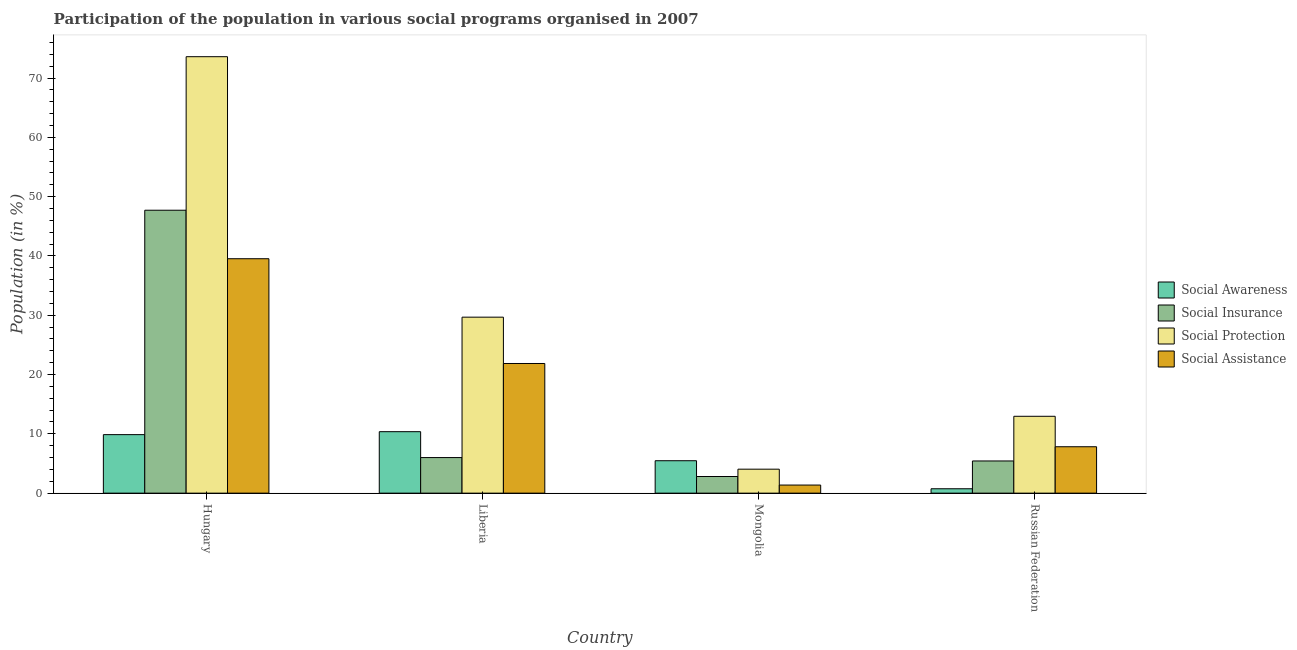How many bars are there on the 2nd tick from the right?
Provide a succinct answer. 4. What is the label of the 2nd group of bars from the left?
Keep it short and to the point. Liberia. In how many cases, is the number of bars for a given country not equal to the number of legend labels?
Provide a short and direct response. 0. What is the participation of population in social assistance programs in Russian Federation?
Ensure brevity in your answer.  7.83. Across all countries, what is the maximum participation of population in social assistance programs?
Your response must be concise. 39.53. Across all countries, what is the minimum participation of population in social protection programs?
Offer a very short reply. 4.04. In which country was the participation of population in social assistance programs maximum?
Your answer should be compact. Hungary. In which country was the participation of population in social awareness programs minimum?
Give a very brief answer. Russian Federation. What is the total participation of population in social assistance programs in the graph?
Your answer should be compact. 70.59. What is the difference between the participation of population in social protection programs in Liberia and that in Russian Federation?
Your answer should be very brief. 16.72. What is the difference between the participation of population in social assistance programs in Liberia and the participation of population in social protection programs in Hungary?
Keep it short and to the point. -51.74. What is the average participation of population in social awareness programs per country?
Offer a very short reply. 6.61. What is the difference between the participation of population in social protection programs and participation of population in social assistance programs in Hungary?
Give a very brief answer. 34.07. In how many countries, is the participation of population in social awareness programs greater than 46 %?
Ensure brevity in your answer.  0. What is the ratio of the participation of population in social insurance programs in Hungary to that in Russian Federation?
Your answer should be compact. 8.79. What is the difference between the highest and the second highest participation of population in social insurance programs?
Provide a short and direct response. 41.71. What is the difference between the highest and the lowest participation of population in social insurance programs?
Make the answer very short. 44.91. Is the sum of the participation of population in social protection programs in Hungary and Mongolia greater than the maximum participation of population in social awareness programs across all countries?
Provide a short and direct response. Yes. Is it the case that in every country, the sum of the participation of population in social awareness programs and participation of population in social protection programs is greater than the sum of participation of population in social assistance programs and participation of population in social insurance programs?
Offer a very short reply. No. What does the 1st bar from the left in Russian Federation represents?
Provide a succinct answer. Social Awareness. What does the 2nd bar from the right in Hungary represents?
Offer a terse response. Social Protection. How many bars are there?
Provide a short and direct response. 16. How many countries are there in the graph?
Provide a succinct answer. 4. What is the difference between two consecutive major ticks on the Y-axis?
Keep it short and to the point. 10. Are the values on the major ticks of Y-axis written in scientific E-notation?
Give a very brief answer. No. Does the graph contain any zero values?
Ensure brevity in your answer.  No. Does the graph contain grids?
Your answer should be compact. No. Where does the legend appear in the graph?
Ensure brevity in your answer.  Center right. How are the legend labels stacked?
Give a very brief answer. Vertical. What is the title of the graph?
Your response must be concise. Participation of the population in various social programs organised in 2007. What is the label or title of the X-axis?
Offer a terse response. Country. What is the Population (in %) in Social Awareness in Hungary?
Offer a very short reply. 9.87. What is the Population (in %) in Social Insurance in Hungary?
Your answer should be very brief. 47.72. What is the Population (in %) in Social Protection in Hungary?
Provide a short and direct response. 73.61. What is the Population (in %) of Social Assistance in Hungary?
Keep it short and to the point. 39.53. What is the Population (in %) in Social Awareness in Liberia?
Provide a succinct answer. 10.37. What is the Population (in %) of Social Insurance in Liberia?
Provide a succinct answer. 6. What is the Population (in %) in Social Protection in Liberia?
Keep it short and to the point. 29.68. What is the Population (in %) in Social Assistance in Liberia?
Make the answer very short. 21.87. What is the Population (in %) of Social Awareness in Mongolia?
Offer a terse response. 5.47. What is the Population (in %) of Social Insurance in Mongolia?
Make the answer very short. 2.8. What is the Population (in %) of Social Protection in Mongolia?
Your answer should be compact. 4.04. What is the Population (in %) in Social Assistance in Mongolia?
Provide a short and direct response. 1.37. What is the Population (in %) in Social Awareness in Russian Federation?
Offer a very short reply. 0.74. What is the Population (in %) in Social Insurance in Russian Federation?
Ensure brevity in your answer.  5.43. What is the Population (in %) in Social Protection in Russian Federation?
Provide a succinct answer. 12.96. What is the Population (in %) of Social Assistance in Russian Federation?
Give a very brief answer. 7.83. Across all countries, what is the maximum Population (in %) of Social Awareness?
Your response must be concise. 10.37. Across all countries, what is the maximum Population (in %) in Social Insurance?
Offer a very short reply. 47.72. Across all countries, what is the maximum Population (in %) in Social Protection?
Your answer should be compact. 73.61. Across all countries, what is the maximum Population (in %) in Social Assistance?
Give a very brief answer. 39.53. Across all countries, what is the minimum Population (in %) in Social Awareness?
Keep it short and to the point. 0.74. Across all countries, what is the minimum Population (in %) of Social Insurance?
Provide a succinct answer. 2.8. Across all countries, what is the minimum Population (in %) in Social Protection?
Your response must be concise. 4.04. Across all countries, what is the minimum Population (in %) of Social Assistance?
Keep it short and to the point. 1.37. What is the total Population (in %) of Social Awareness in the graph?
Your answer should be compact. 26.44. What is the total Population (in %) in Social Insurance in the graph?
Provide a succinct answer. 61.95. What is the total Population (in %) of Social Protection in the graph?
Offer a very short reply. 120.29. What is the total Population (in %) in Social Assistance in the graph?
Offer a very short reply. 70.59. What is the difference between the Population (in %) in Social Awareness in Hungary and that in Liberia?
Make the answer very short. -0.5. What is the difference between the Population (in %) of Social Insurance in Hungary and that in Liberia?
Ensure brevity in your answer.  41.71. What is the difference between the Population (in %) of Social Protection in Hungary and that in Liberia?
Ensure brevity in your answer.  43.93. What is the difference between the Population (in %) of Social Assistance in Hungary and that in Liberia?
Ensure brevity in your answer.  17.67. What is the difference between the Population (in %) of Social Awareness in Hungary and that in Mongolia?
Your answer should be very brief. 4.4. What is the difference between the Population (in %) of Social Insurance in Hungary and that in Mongolia?
Your answer should be compact. 44.91. What is the difference between the Population (in %) in Social Protection in Hungary and that in Mongolia?
Provide a succinct answer. 69.57. What is the difference between the Population (in %) in Social Assistance in Hungary and that in Mongolia?
Provide a short and direct response. 38.17. What is the difference between the Population (in %) in Social Awareness in Hungary and that in Russian Federation?
Your answer should be very brief. 9.13. What is the difference between the Population (in %) of Social Insurance in Hungary and that in Russian Federation?
Offer a very short reply. 42.29. What is the difference between the Population (in %) of Social Protection in Hungary and that in Russian Federation?
Offer a terse response. 60.65. What is the difference between the Population (in %) in Social Assistance in Hungary and that in Russian Federation?
Keep it short and to the point. 31.71. What is the difference between the Population (in %) in Social Awareness in Liberia and that in Mongolia?
Make the answer very short. 4.9. What is the difference between the Population (in %) in Social Insurance in Liberia and that in Mongolia?
Provide a succinct answer. 3.2. What is the difference between the Population (in %) of Social Protection in Liberia and that in Mongolia?
Keep it short and to the point. 25.64. What is the difference between the Population (in %) in Social Assistance in Liberia and that in Mongolia?
Your answer should be compact. 20.5. What is the difference between the Population (in %) in Social Awareness in Liberia and that in Russian Federation?
Make the answer very short. 9.63. What is the difference between the Population (in %) of Social Insurance in Liberia and that in Russian Federation?
Provide a short and direct response. 0.57. What is the difference between the Population (in %) of Social Protection in Liberia and that in Russian Federation?
Provide a succinct answer. 16.72. What is the difference between the Population (in %) in Social Assistance in Liberia and that in Russian Federation?
Your response must be concise. 14.04. What is the difference between the Population (in %) in Social Awareness in Mongolia and that in Russian Federation?
Provide a succinct answer. 4.73. What is the difference between the Population (in %) of Social Insurance in Mongolia and that in Russian Federation?
Make the answer very short. -2.62. What is the difference between the Population (in %) in Social Protection in Mongolia and that in Russian Federation?
Your response must be concise. -8.92. What is the difference between the Population (in %) of Social Assistance in Mongolia and that in Russian Federation?
Your response must be concise. -6.46. What is the difference between the Population (in %) of Social Awareness in Hungary and the Population (in %) of Social Insurance in Liberia?
Provide a short and direct response. 3.87. What is the difference between the Population (in %) of Social Awareness in Hungary and the Population (in %) of Social Protection in Liberia?
Offer a terse response. -19.81. What is the difference between the Population (in %) of Social Awareness in Hungary and the Population (in %) of Social Assistance in Liberia?
Your response must be concise. -12. What is the difference between the Population (in %) of Social Insurance in Hungary and the Population (in %) of Social Protection in Liberia?
Provide a short and direct response. 18.04. What is the difference between the Population (in %) of Social Insurance in Hungary and the Population (in %) of Social Assistance in Liberia?
Your answer should be very brief. 25.85. What is the difference between the Population (in %) in Social Protection in Hungary and the Population (in %) in Social Assistance in Liberia?
Your answer should be compact. 51.74. What is the difference between the Population (in %) of Social Awareness in Hungary and the Population (in %) of Social Insurance in Mongolia?
Provide a short and direct response. 7.06. What is the difference between the Population (in %) in Social Awareness in Hungary and the Population (in %) in Social Protection in Mongolia?
Provide a succinct answer. 5.83. What is the difference between the Population (in %) of Social Awareness in Hungary and the Population (in %) of Social Assistance in Mongolia?
Your answer should be very brief. 8.5. What is the difference between the Population (in %) in Social Insurance in Hungary and the Population (in %) in Social Protection in Mongolia?
Make the answer very short. 43.67. What is the difference between the Population (in %) in Social Insurance in Hungary and the Population (in %) in Social Assistance in Mongolia?
Give a very brief answer. 46.35. What is the difference between the Population (in %) in Social Protection in Hungary and the Population (in %) in Social Assistance in Mongolia?
Keep it short and to the point. 72.24. What is the difference between the Population (in %) of Social Awareness in Hungary and the Population (in %) of Social Insurance in Russian Federation?
Your answer should be very brief. 4.44. What is the difference between the Population (in %) of Social Awareness in Hungary and the Population (in %) of Social Protection in Russian Federation?
Ensure brevity in your answer.  -3.09. What is the difference between the Population (in %) of Social Awareness in Hungary and the Population (in %) of Social Assistance in Russian Federation?
Provide a short and direct response. 2.04. What is the difference between the Population (in %) of Social Insurance in Hungary and the Population (in %) of Social Protection in Russian Federation?
Ensure brevity in your answer.  34.75. What is the difference between the Population (in %) in Social Insurance in Hungary and the Population (in %) in Social Assistance in Russian Federation?
Provide a short and direct response. 39.89. What is the difference between the Population (in %) in Social Protection in Hungary and the Population (in %) in Social Assistance in Russian Federation?
Offer a terse response. 65.78. What is the difference between the Population (in %) in Social Awareness in Liberia and the Population (in %) in Social Insurance in Mongolia?
Your answer should be very brief. 7.56. What is the difference between the Population (in %) of Social Awareness in Liberia and the Population (in %) of Social Protection in Mongolia?
Provide a short and direct response. 6.32. What is the difference between the Population (in %) of Social Awareness in Liberia and the Population (in %) of Social Assistance in Mongolia?
Offer a terse response. 9. What is the difference between the Population (in %) in Social Insurance in Liberia and the Population (in %) in Social Protection in Mongolia?
Your answer should be very brief. 1.96. What is the difference between the Population (in %) in Social Insurance in Liberia and the Population (in %) in Social Assistance in Mongolia?
Provide a succinct answer. 4.64. What is the difference between the Population (in %) of Social Protection in Liberia and the Population (in %) of Social Assistance in Mongolia?
Give a very brief answer. 28.31. What is the difference between the Population (in %) in Social Awareness in Liberia and the Population (in %) in Social Insurance in Russian Federation?
Provide a short and direct response. 4.94. What is the difference between the Population (in %) in Social Awareness in Liberia and the Population (in %) in Social Protection in Russian Federation?
Offer a very short reply. -2.6. What is the difference between the Population (in %) in Social Awareness in Liberia and the Population (in %) in Social Assistance in Russian Federation?
Give a very brief answer. 2.54. What is the difference between the Population (in %) of Social Insurance in Liberia and the Population (in %) of Social Protection in Russian Federation?
Your answer should be very brief. -6.96. What is the difference between the Population (in %) of Social Insurance in Liberia and the Population (in %) of Social Assistance in Russian Federation?
Your answer should be very brief. -1.82. What is the difference between the Population (in %) of Social Protection in Liberia and the Population (in %) of Social Assistance in Russian Federation?
Keep it short and to the point. 21.85. What is the difference between the Population (in %) in Social Awareness in Mongolia and the Population (in %) in Social Insurance in Russian Federation?
Offer a very short reply. 0.04. What is the difference between the Population (in %) of Social Awareness in Mongolia and the Population (in %) of Social Protection in Russian Federation?
Provide a succinct answer. -7.49. What is the difference between the Population (in %) in Social Awareness in Mongolia and the Population (in %) in Social Assistance in Russian Federation?
Offer a very short reply. -2.36. What is the difference between the Population (in %) of Social Insurance in Mongolia and the Population (in %) of Social Protection in Russian Federation?
Make the answer very short. -10.16. What is the difference between the Population (in %) of Social Insurance in Mongolia and the Population (in %) of Social Assistance in Russian Federation?
Ensure brevity in your answer.  -5.02. What is the difference between the Population (in %) of Social Protection in Mongolia and the Population (in %) of Social Assistance in Russian Federation?
Provide a succinct answer. -3.78. What is the average Population (in %) in Social Awareness per country?
Your answer should be compact. 6.61. What is the average Population (in %) in Social Insurance per country?
Give a very brief answer. 15.49. What is the average Population (in %) in Social Protection per country?
Your answer should be compact. 30.07. What is the average Population (in %) in Social Assistance per country?
Your answer should be very brief. 17.65. What is the difference between the Population (in %) in Social Awareness and Population (in %) in Social Insurance in Hungary?
Your answer should be very brief. -37.85. What is the difference between the Population (in %) of Social Awareness and Population (in %) of Social Protection in Hungary?
Offer a terse response. -63.74. What is the difference between the Population (in %) in Social Awareness and Population (in %) in Social Assistance in Hungary?
Your response must be concise. -29.67. What is the difference between the Population (in %) in Social Insurance and Population (in %) in Social Protection in Hungary?
Offer a terse response. -25.89. What is the difference between the Population (in %) in Social Insurance and Population (in %) in Social Assistance in Hungary?
Provide a short and direct response. 8.18. What is the difference between the Population (in %) in Social Protection and Population (in %) in Social Assistance in Hungary?
Your answer should be compact. 34.07. What is the difference between the Population (in %) of Social Awareness and Population (in %) of Social Insurance in Liberia?
Offer a terse response. 4.37. What is the difference between the Population (in %) in Social Awareness and Population (in %) in Social Protection in Liberia?
Keep it short and to the point. -19.31. What is the difference between the Population (in %) in Social Awareness and Population (in %) in Social Assistance in Liberia?
Your answer should be compact. -11.5. What is the difference between the Population (in %) in Social Insurance and Population (in %) in Social Protection in Liberia?
Keep it short and to the point. -23.68. What is the difference between the Population (in %) in Social Insurance and Population (in %) in Social Assistance in Liberia?
Give a very brief answer. -15.87. What is the difference between the Population (in %) in Social Protection and Population (in %) in Social Assistance in Liberia?
Keep it short and to the point. 7.81. What is the difference between the Population (in %) of Social Awareness and Population (in %) of Social Insurance in Mongolia?
Make the answer very short. 2.66. What is the difference between the Population (in %) of Social Awareness and Population (in %) of Social Protection in Mongolia?
Your answer should be compact. 1.43. What is the difference between the Population (in %) in Social Awareness and Population (in %) in Social Assistance in Mongolia?
Keep it short and to the point. 4.1. What is the difference between the Population (in %) of Social Insurance and Population (in %) of Social Protection in Mongolia?
Your answer should be very brief. -1.24. What is the difference between the Population (in %) in Social Insurance and Population (in %) in Social Assistance in Mongolia?
Provide a short and direct response. 1.44. What is the difference between the Population (in %) in Social Protection and Population (in %) in Social Assistance in Mongolia?
Make the answer very short. 2.68. What is the difference between the Population (in %) of Social Awareness and Population (in %) of Social Insurance in Russian Federation?
Give a very brief answer. -4.69. What is the difference between the Population (in %) in Social Awareness and Population (in %) in Social Protection in Russian Federation?
Offer a terse response. -12.22. What is the difference between the Population (in %) of Social Awareness and Population (in %) of Social Assistance in Russian Federation?
Provide a succinct answer. -7.08. What is the difference between the Population (in %) in Social Insurance and Population (in %) in Social Protection in Russian Federation?
Offer a terse response. -7.53. What is the difference between the Population (in %) in Social Insurance and Population (in %) in Social Assistance in Russian Federation?
Provide a short and direct response. -2.4. What is the difference between the Population (in %) of Social Protection and Population (in %) of Social Assistance in Russian Federation?
Your answer should be compact. 5.14. What is the ratio of the Population (in %) in Social Insurance in Hungary to that in Liberia?
Your answer should be compact. 7.95. What is the ratio of the Population (in %) in Social Protection in Hungary to that in Liberia?
Your response must be concise. 2.48. What is the ratio of the Population (in %) in Social Assistance in Hungary to that in Liberia?
Keep it short and to the point. 1.81. What is the ratio of the Population (in %) in Social Awareness in Hungary to that in Mongolia?
Provide a short and direct response. 1.8. What is the ratio of the Population (in %) of Social Insurance in Hungary to that in Mongolia?
Give a very brief answer. 17.01. What is the ratio of the Population (in %) of Social Protection in Hungary to that in Mongolia?
Your response must be concise. 18.21. What is the ratio of the Population (in %) of Social Assistance in Hungary to that in Mongolia?
Your response must be concise. 28.96. What is the ratio of the Population (in %) in Social Awareness in Hungary to that in Russian Federation?
Offer a terse response. 13.33. What is the ratio of the Population (in %) of Social Insurance in Hungary to that in Russian Federation?
Ensure brevity in your answer.  8.79. What is the ratio of the Population (in %) in Social Protection in Hungary to that in Russian Federation?
Ensure brevity in your answer.  5.68. What is the ratio of the Population (in %) in Social Assistance in Hungary to that in Russian Federation?
Make the answer very short. 5.05. What is the ratio of the Population (in %) of Social Awareness in Liberia to that in Mongolia?
Provide a succinct answer. 1.9. What is the ratio of the Population (in %) of Social Insurance in Liberia to that in Mongolia?
Your response must be concise. 2.14. What is the ratio of the Population (in %) in Social Protection in Liberia to that in Mongolia?
Keep it short and to the point. 7.34. What is the ratio of the Population (in %) in Social Assistance in Liberia to that in Mongolia?
Your answer should be compact. 16.02. What is the ratio of the Population (in %) in Social Awareness in Liberia to that in Russian Federation?
Your response must be concise. 14. What is the ratio of the Population (in %) in Social Insurance in Liberia to that in Russian Federation?
Your response must be concise. 1.11. What is the ratio of the Population (in %) in Social Protection in Liberia to that in Russian Federation?
Offer a very short reply. 2.29. What is the ratio of the Population (in %) of Social Assistance in Liberia to that in Russian Federation?
Ensure brevity in your answer.  2.79. What is the ratio of the Population (in %) of Social Awareness in Mongolia to that in Russian Federation?
Offer a very short reply. 7.39. What is the ratio of the Population (in %) in Social Insurance in Mongolia to that in Russian Federation?
Give a very brief answer. 0.52. What is the ratio of the Population (in %) in Social Protection in Mongolia to that in Russian Federation?
Give a very brief answer. 0.31. What is the ratio of the Population (in %) in Social Assistance in Mongolia to that in Russian Federation?
Ensure brevity in your answer.  0.17. What is the difference between the highest and the second highest Population (in %) of Social Awareness?
Offer a very short reply. 0.5. What is the difference between the highest and the second highest Population (in %) of Social Insurance?
Offer a terse response. 41.71. What is the difference between the highest and the second highest Population (in %) in Social Protection?
Offer a very short reply. 43.93. What is the difference between the highest and the second highest Population (in %) in Social Assistance?
Make the answer very short. 17.67. What is the difference between the highest and the lowest Population (in %) of Social Awareness?
Keep it short and to the point. 9.63. What is the difference between the highest and the lowest Population (in %) in Social Insurance?
Your answer should be very brief. 44.91. What is the difference between the highest and the lowest Population (in %) in Social Protection?
Offer a very short reply. 69.57. What is the difference between the highest and the lowest Population (in %) of Social Assistance?
Make the answer very short. 38.17. 